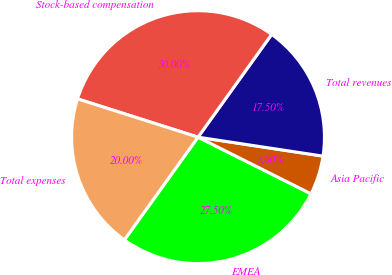<chart> <loc_0><loc_0><loc_500><loc_500><pie_chart><fcel>EMEA<fcel>Asia Pacific<fcel>Total revenues<fcel>Stock-based compensation<fcel>Total expenses<nl><fcel>27.5%<fcel>5.0%<fcel>17.5%<fcel>30.0%<fcel>20.0%<nl></chart> 